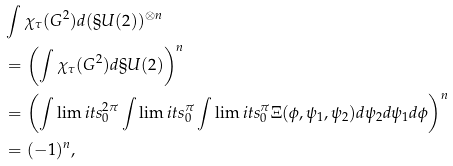Convert formula to latex. <formula><loc_0><loc_0><loc_500><loc_500>& \int \chi _ { \tau } ( G ^ { 2 } ) d ( \S U ( 2 ) ) ^ { \otimes n } \\ & = \left ( \int \chi _ { \tau } ( G ^ { 2 } ) d \S U ( 2 ) \right ) ^ { n } \\ & = \left ( \int \lim i t s _ { 0 } ^ { 2 \pi } \int \lim i t s _ { 0 } ^ { \pi } \int \lim i t s _ { 0 } ^ { \pi } \Xi ( \phi , \psi _ { 1 } , \psi _ { 2 } ) d \psi _ { 2 } d \psi _ { 1 } d \phi \right ) ^ { n } \\ & = ( - 1 ) ^ { n } ,</formula> 